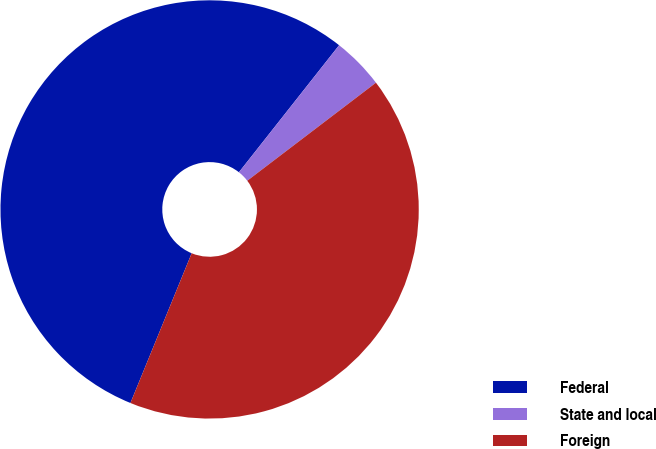Convert chart. <chart><loc_0><loc_0><loc_500><loc_500><pie_chart><fcel>Federal<fcel>State and local<fcel>Foreign<nl><fcel>54.45%<fcel>4.01%<fcel>41.54%<nl></chart> 